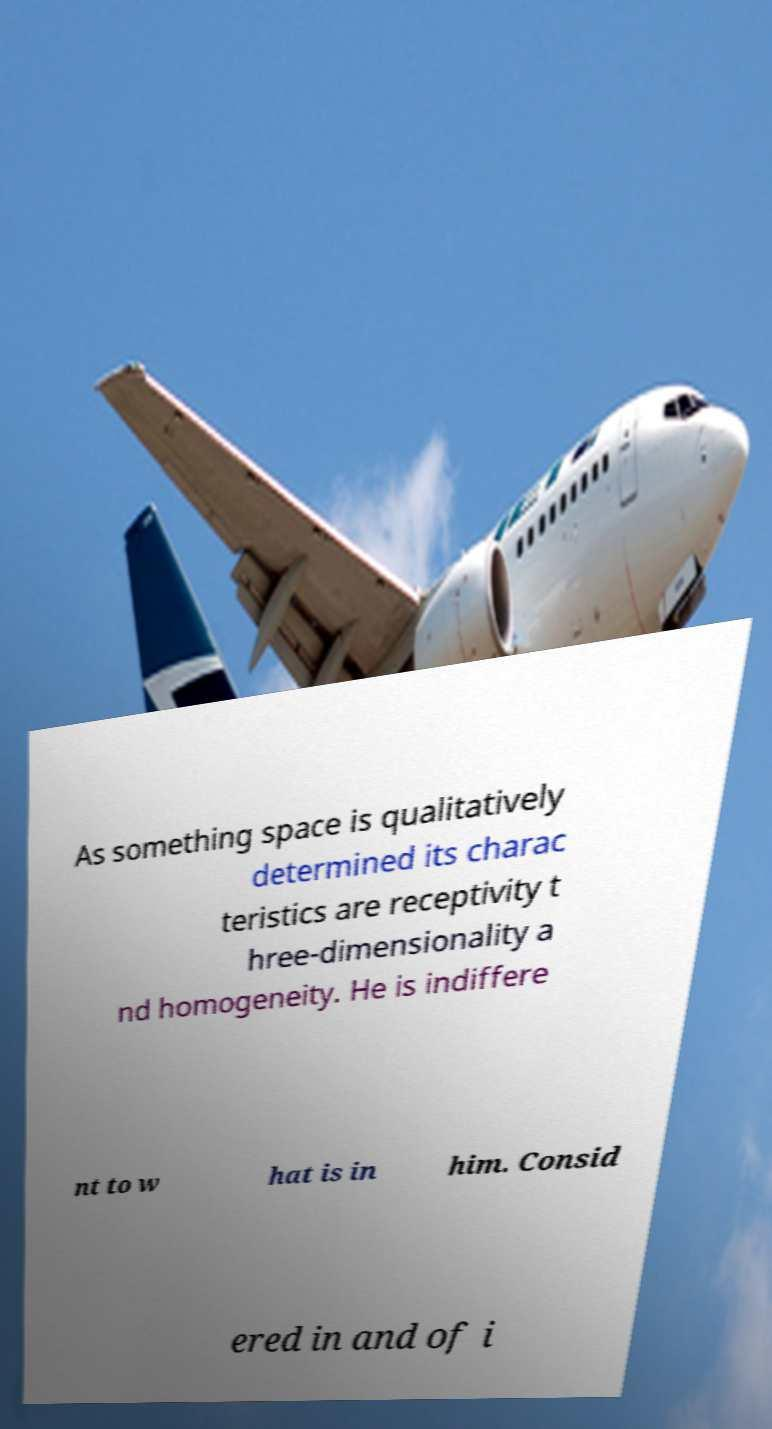Could you assist in decoding the text presented in this image and type it out clearly? As something space is qualitatively determined its charac teristics are receptivity t hree-dimensionality a nd homogeneity. He is indiffere nt to w hat is in him. Consid ered in and of i 